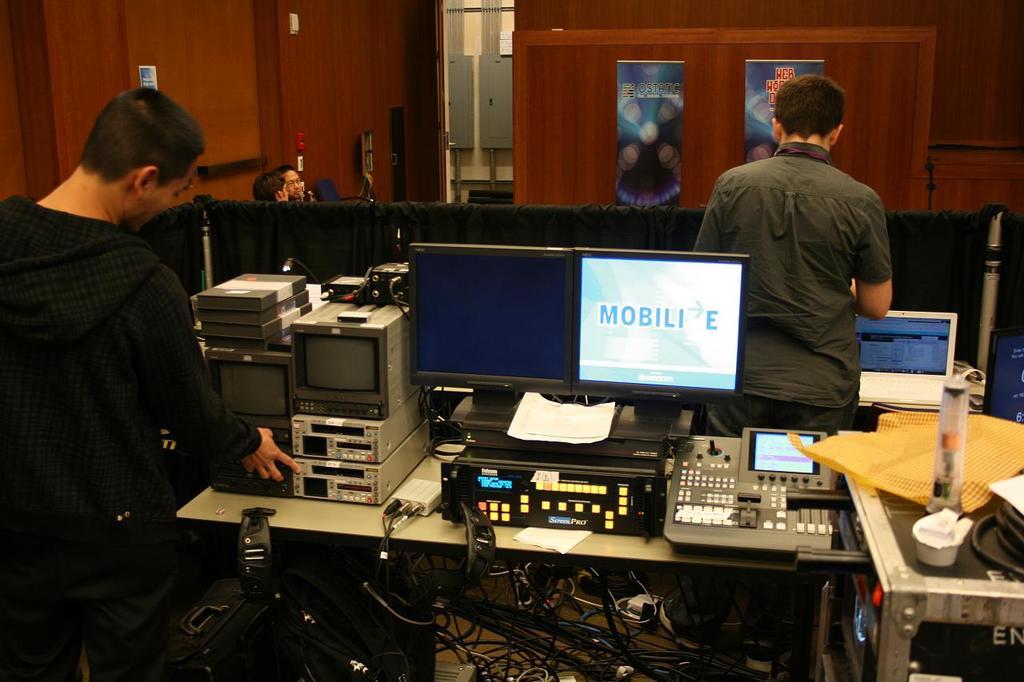What is written on the computer screen?
Make the answer very short. Mobili e. 